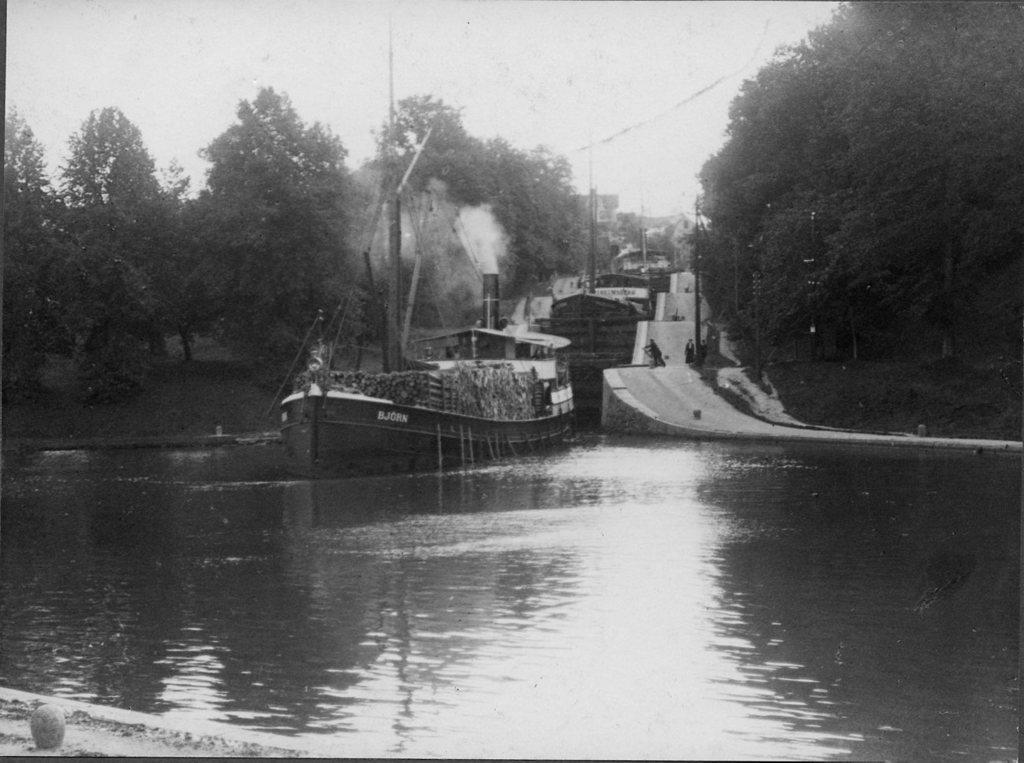What is the color scheme of the image? The image is black and white. What can be seen in the water in the image? There is a boat in the water. What type of man-made structure is visible in the image? There is a road visible in the image. What type of natural vegetation is present in the image? There are trees in the image. What part of the natural environment is visible in the image? The sky is visible in the image. What type of milk is being served by the maid in the image? There is no maid or milk present in the image. What type of guide is visible in the image? There is no guide present in the image. 